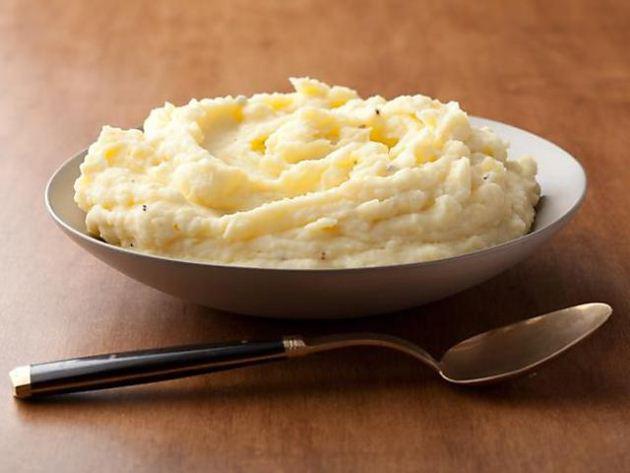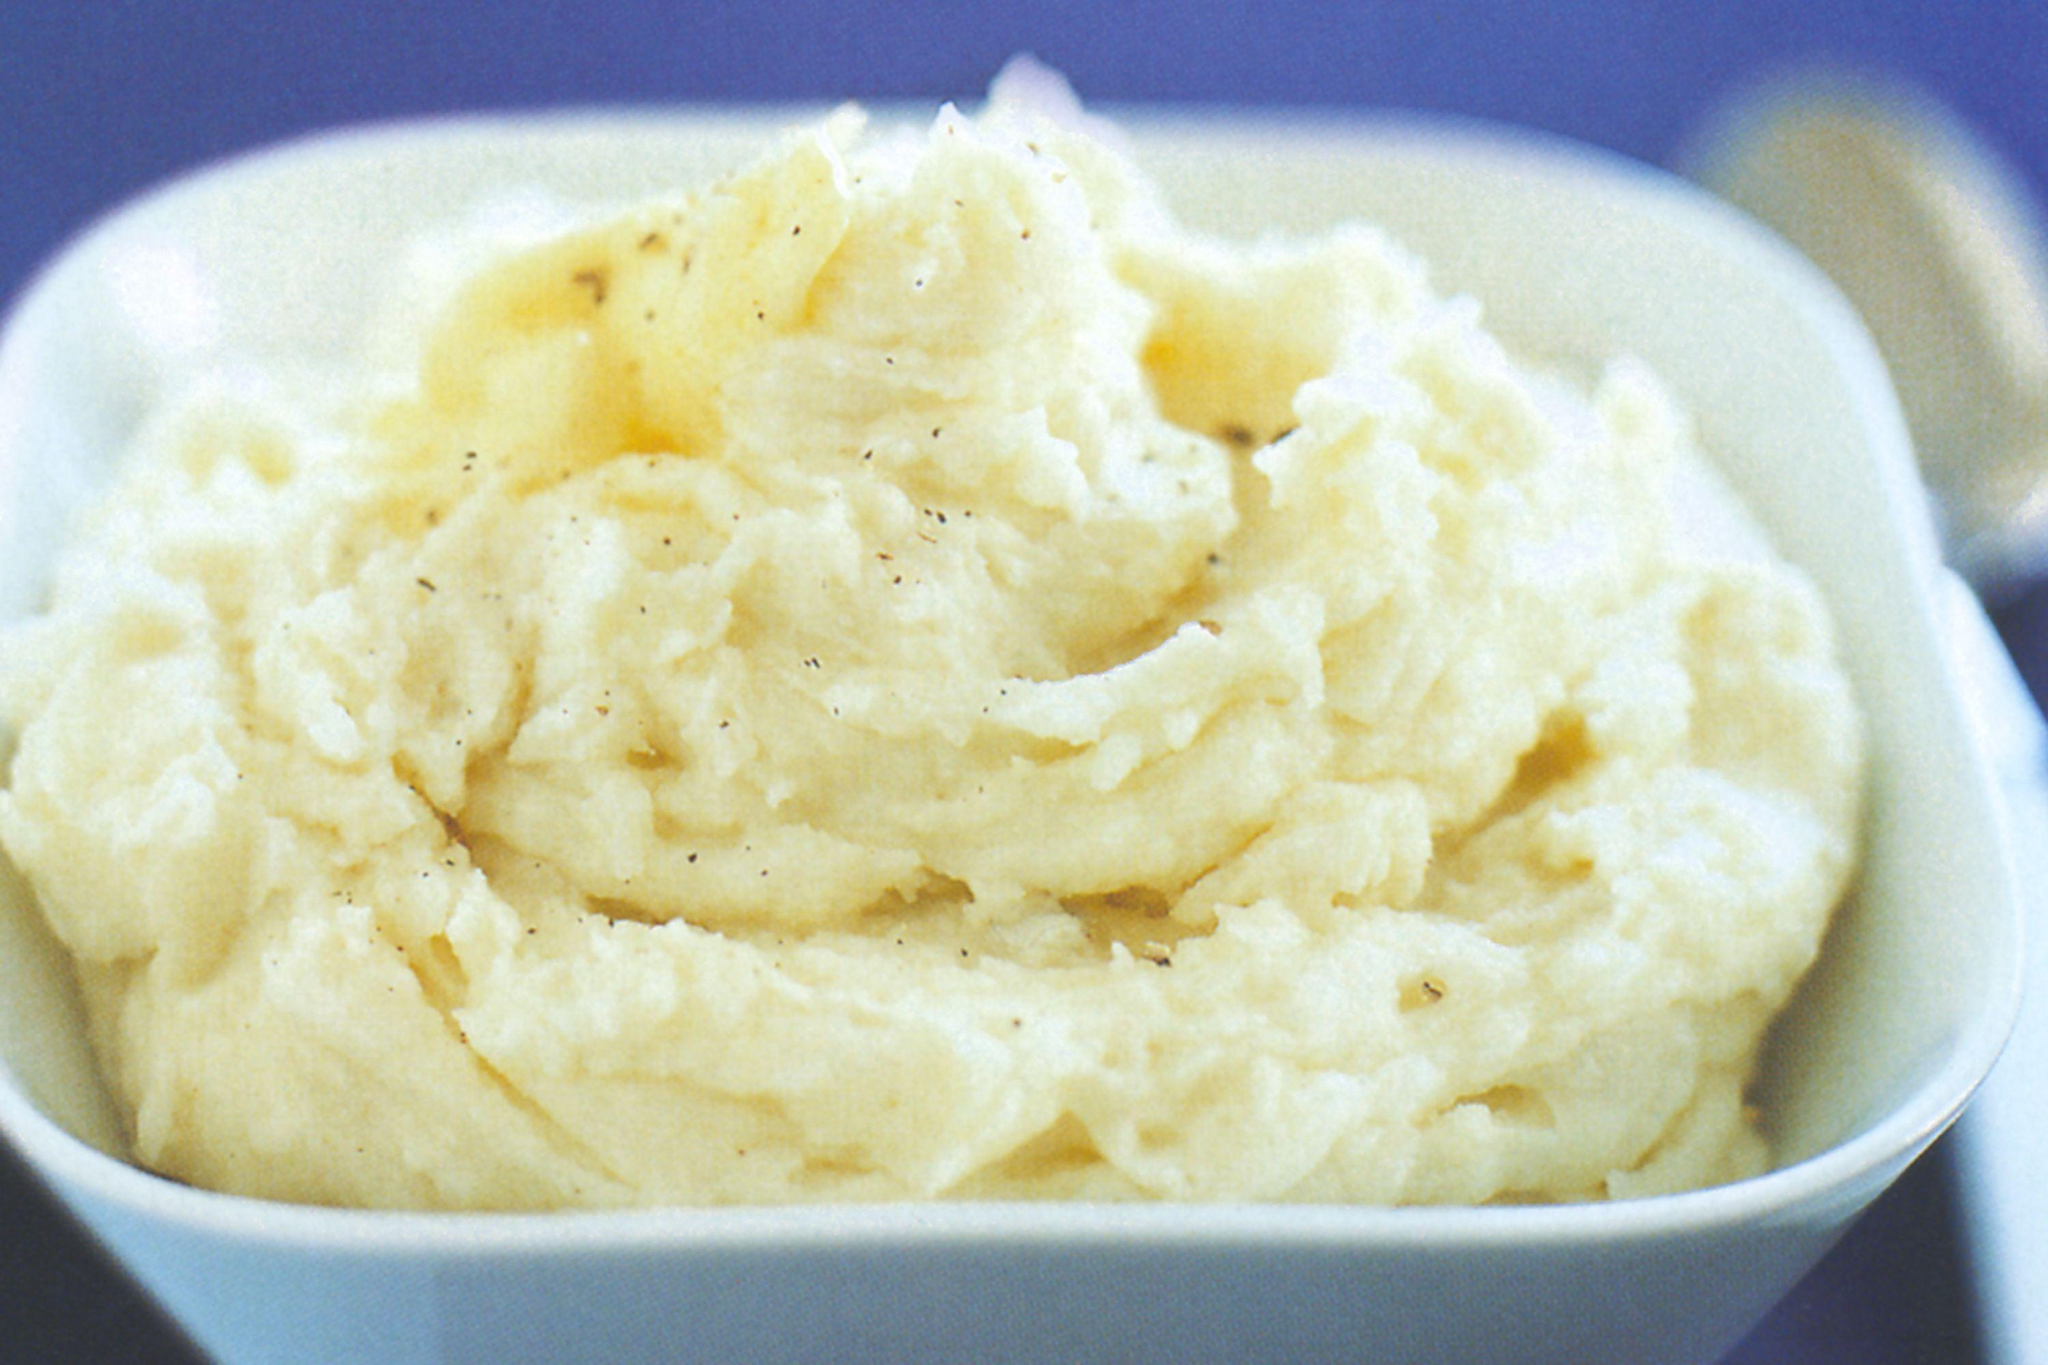The first image is the image on the left, the second image is the image on the right. Considering the images on both sides, is "In one image, mashed potatoes are served in a red bowl with a pat of butter and chopped chives." valid? Answer yes or no. No. The first image is the image on the left, the second image is the image on the right. Analyze the images presented: Is the assertion "An image shows a red container with a fork next to it." valid? Answer yes or no. No. 